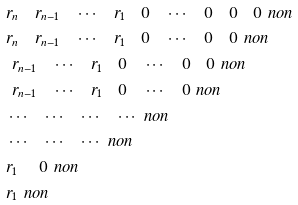<formula> <loc_0><loc_0><loc_500><loc_500>& \quad r _ { n } \quad r _ { n - 1 } \quad \cdots \quad r _ { 1 } \quad 0 \quad \cdots \quad 0 \quad 0 \quad 0 \ n o n \\ & \quad r _ { n } \quad r _ { n - 1 } \quad \cdots \quad r _ { 1 } \quad 0 \quad \cdots \quad 0 \quad 0 \ n o n \\ & \quad \ r _ { n - 1 } \quad \cdots \quad r _ { 1 } \quad 0 \quad \cdots \quad 0 \quad 0 \ n o n \\ & \quad \ r _ { n - 1 } \quad \cdots \quad r _ { 1 } \quad 0 \quad \cdots \quad 0 \ n o n \\ & \quad \cdots \quad \cdots \quad \cdots \quad \cdots \ n o n \\ & \quad \cdots \quad \cdots \quad \cdots \ n o n \\ & \quad r _ { 1 } \quad \ 0 \ n o n \\ & \quad r _ { 1 } \ n o n</formula> 